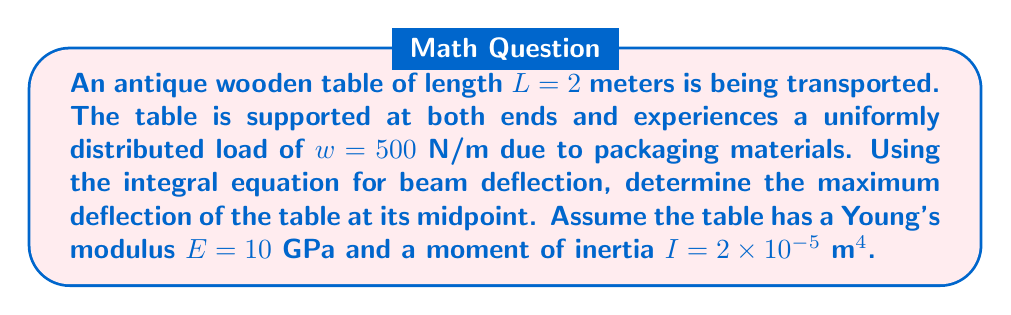Solve this math problem. 1) The integral equation for beam deflection under a uniformly distributed load is:

   $$\frac{d^2y}{dx^2} = \frac{M(x)}{EI}$$

   where $M(x)$ is the bending moment at any point $x$.

2) For a simply supported beam with uniformly distributed load, the bending moment is:

   $$M(x) = \frac{wx}{2}(L-x)$$

3) Substituting this into the beam equation:

   $$\frac{d^2y}{dx^2} = \frac{wx(L-x)}{2EI}$$

4) Integrating twice:

   $$\frac{dy}{dx} = \frac{w}{2EI}\left(\frac{Lx^2}{2} - \frac{x^3}{3}\right) + C_1$$

   $$y = \frac{w}{2EI}\left(\frac{Lx^3}{6} - \frac{x^4}{12}\right) + C_1x + C_2$$

5) Using boundary conditions $y(0) = y(L) = 0$, we can solve for $C_1$ and $C_2$:

   $C_2 = 0$ and $C_1 = -\frac{wL^3}{24EI}$

6) The deflection equation becomes:

   $$y = \frac{w}{24EI}(Lx^3 - 2x^4 - L^3x)$$

7) The maximum deflection occurs at the midpoint $(x = L/2)$:

   $$y_{max} = \frac{5wL^4}{384EI}$$

8) Substituting the given values:

   $$y_{max} = \frac{5 \cdot 500 \cdot 2^4}{384 \cdot 10 \cdot 10^9 \cdot 2 \cdot 10^{-5}} = 1.302 \times 10^{-4}\ \text{m}$$
Answer: $1.302 \times 10^{-4}$ m 